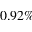Convert formula to latex. <formula><loc_0><loc_0><loc_500><loc_500>0 . 9 2 \%</formula> 